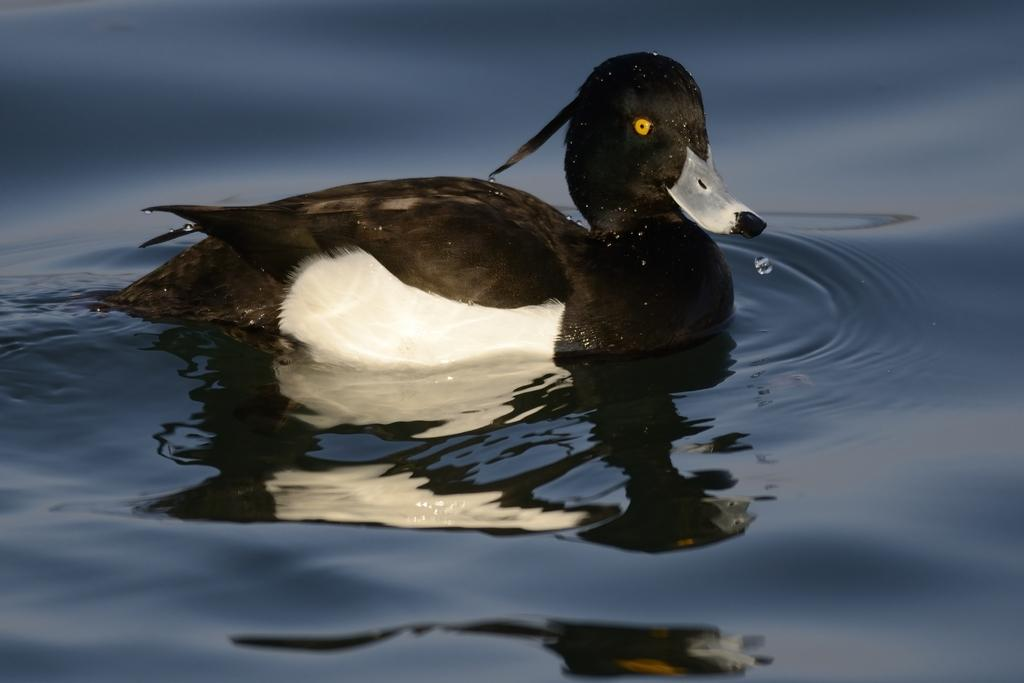Where was the image taken? The image is taken outdoors. What can be seen at the bottom of the image? There is a pond with water at the bottom of the image. What animal is present in the pond? There is a duck in the pond in the middle of the image. What type of juice can be seen dripping from the icicle in the image? There is no juice or icicle present in the image; it features a pond with a duck. 